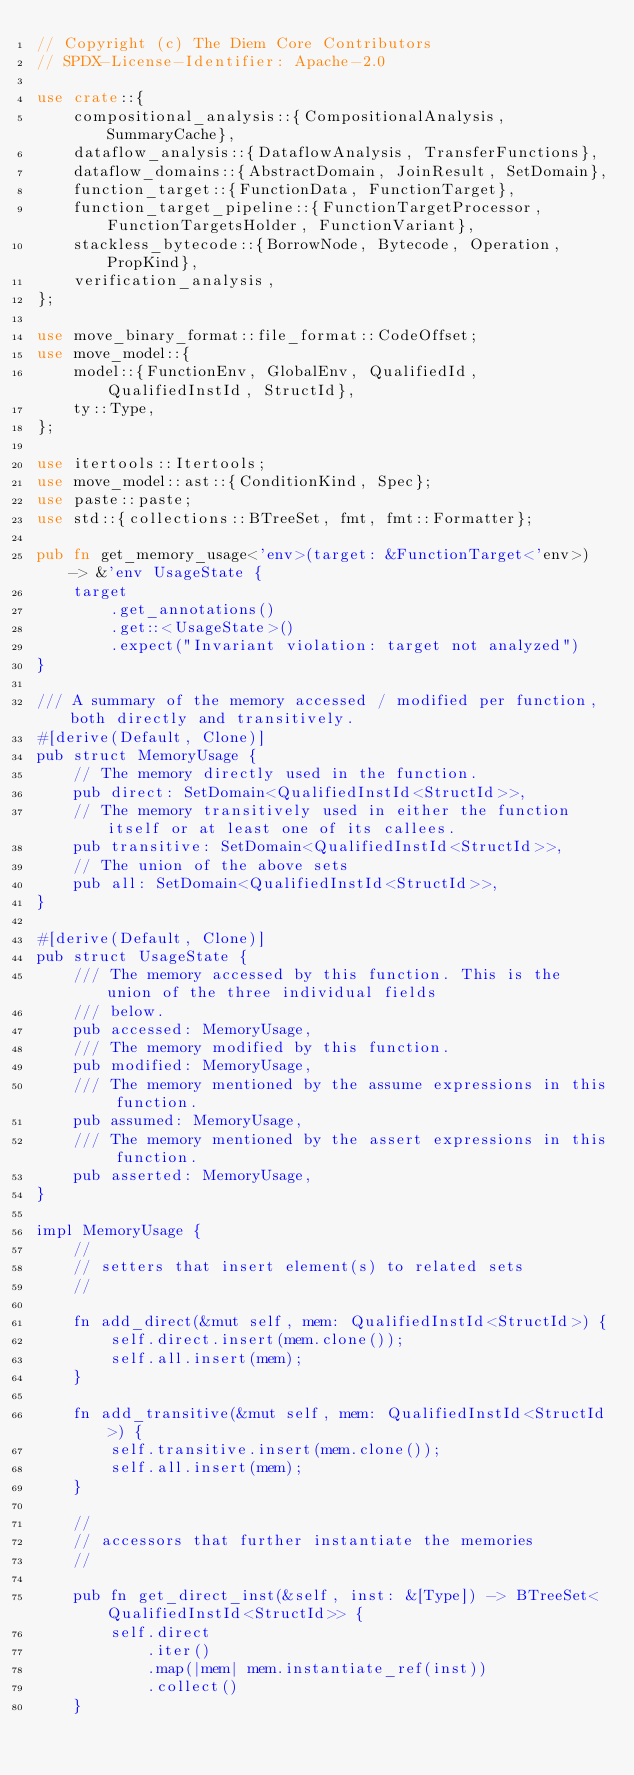Convert code to text. <code><loc_0><loc_0><loc_500><loc_500><_Rust_>// Copyright (c) The Diem Core Contributors
// SPDX-License-Identifier: Apache-2.0

use crate::{
    compositional_analysis::{CompositionalAnalysis, SummaryCache},
    dataflow_analysis::{DataflowAnalysis, TransferFunctions},
    dataflow_domains::{AbstractDomain, JoinResult, SetDomain},
    function_target::{FunctionData, FunctionTarget},
    function_target_pipeline::{FunctionTargetProcessor, FunctionTargetsHolder, FunctionVariant},
    stackless_bytecode::{BorrowNode, Bytecode, Operation, PropKind},
    verification_analysis,
};

use move_binary_format::file_format::CodeOffset;
use move_model::{
    model::{FunctionEnv, GlobalEnv, QualifiedId, QualifiedInstId, StructId},
    ty::Type,
};

use itertools::Itertools;
use move_model::ast::{ConditionKind, Spec};
use paste::paste;
use std::{collections::BTreeSet, fmt, fmt::Formatter};

pub fn get_memory_usage<'env>(target: &FunctionTarget<'env>) -> &'env UsageState {
    target
        .get_annotations()
        .get::<UsageState>()
        .expect("Invariant violation: target not analyzed")
}

/// A summary of the memory accessed / modified per function, both directly and transitively.
#[derive(Default, Clone)]
pub struct MemoryUsage {
    // The memory directly used in the function.
    pub direct: SetDomain<QualifiedInstId<StructId>>,
    // The memory transitively used in either the function itself or at least one of its callees.
    pub transitive: SetDomain<QualifiedInstId<StructId>>,
    // The union of the above sets
    pub all: SetDomain<QualifiedInstId<StructId>>,
}

#[derive(Default, Clone)]
pub struct UsageState {
    /// The memory accessed by this function. This is the union of the three individual fields
    /// below.
    pub accessed: MemoryUsage,
    /// The memory modified by this function.
    pub modified: MemoryUsage,
    /// The memory mentioned by the assume expressions in this function.
    pub assumed: MemoryUsage,
    /// The memory mentioned by the assert expressions in this function.
    pub asserted: MemoryUsage,
}

impl MemoryUsage {
    //
    // setters that insert element(s) to related sets
    //

    fn add_direct(&mut self, mem: QualifiedInstId<StructId>) {
        self.direct.insert(mem.clone());
        self.all.insert(mem);
    }

    fn add_transitive(&mut self, mem: QualifiedInstId<StructId>) {
        self.transitive.insert(mem.clone());
        self.all.insert(mem);
    }

    //
    // accessors that further instantiate the memories
    //

    pub fn get_direct_inst(&self, inst: &[Type]) -> BTreeSet<QualifiedInstId<StructId>> {
        self.direct
            .iter()
            .map(|mem| mem.instantiate_ref(inst))
            .collect()
    }
</code> 